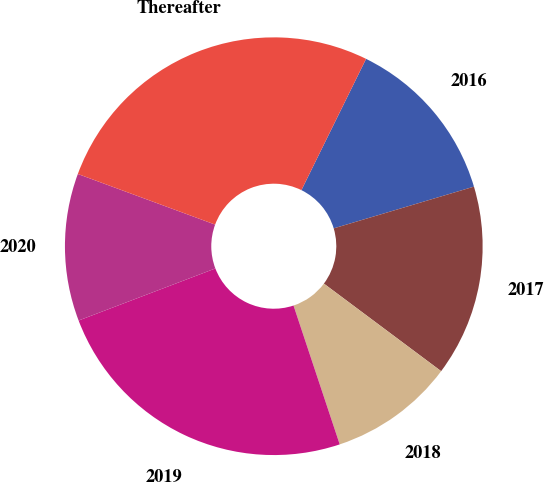Convert chart. <chart><loc_0><loc_0><loc_500><loc_500><pie_chart><fcel>2016<fcel>2017<fcel>2018<fcel>2019<fcel>2020<fcel>Thereafter<nl><fcel>13.11%<fcel>14.81%<fcel>9.68%<fcel>24.32%<fcel>11.41%<fcel>26.66%<nl></chart> 